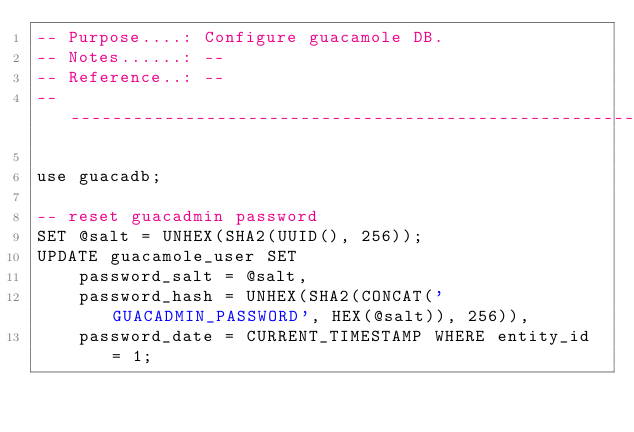<code> <loc_0><loc_0><loc_500><loc_500><_SQL_>-- Purpose....: Configure guacamole DB.
-- Notes......: --
-- Reference..: --
-- --------------------------------------------------------------------------

use guacadb;

-- reset guacadmin password
SET @salt = UNHEX(SHA2(UUID(), 256));
UPDATE guacamole_user SET 
    password_salt = @salt,
    password_hash = UNHEX(SHA2(CONCAT('GUACADMIN_PASSWORD', HEX(@salt)), 256)),
    password_date = CURRENT_TIMESTAMP WHERE entity_id = 1;
</code> 